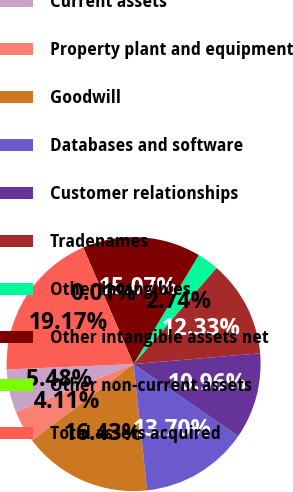<chart> <loc_0><loc_0><loc_500><loc_500><pie_chart><fcel>Current assets<fcel>Property plant and equipment<fcel>Goodwill<fcel>Databases and software<fcel>Customer relationships<fcel>Tradenames<fcel>Other intangibles<fcel>Other intangible assets net<fcel>Other non-current assets<fcel>Total assets acquired<nl><fcel>5.48%<fcel>4.11%<fcel>16.43%<fcel>13.7%<fcel>10.96%<fcel>12.33%<fcel>2.74%<fcel>15.07%<fcel>0.01%<fcel>19.17%<nl></chart> 